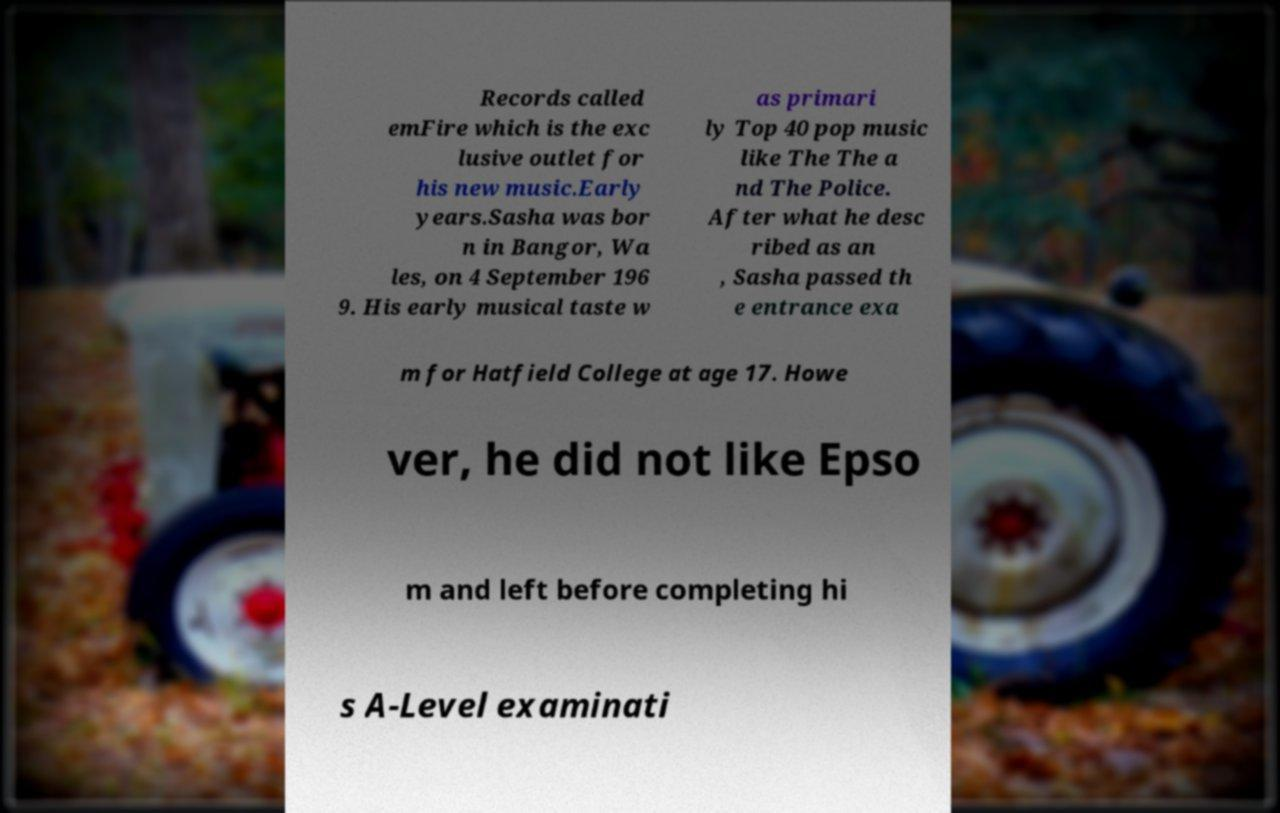Could you extract and type out the text from this image? Records called emFire which is the exc lusive outlet for his new music.Early years.Sasha was bor n in Bangor, Wa les, on 4 September 196 9. His early musical taste w as primari ly Top 40 pop music like The The a nd The Police. After what he desc ribed as an , Sasha passed th e entrance exa m for Hatfield College at age 17. Howe ver, he did not like Epso m and left before completing hi s A-Level examinati 